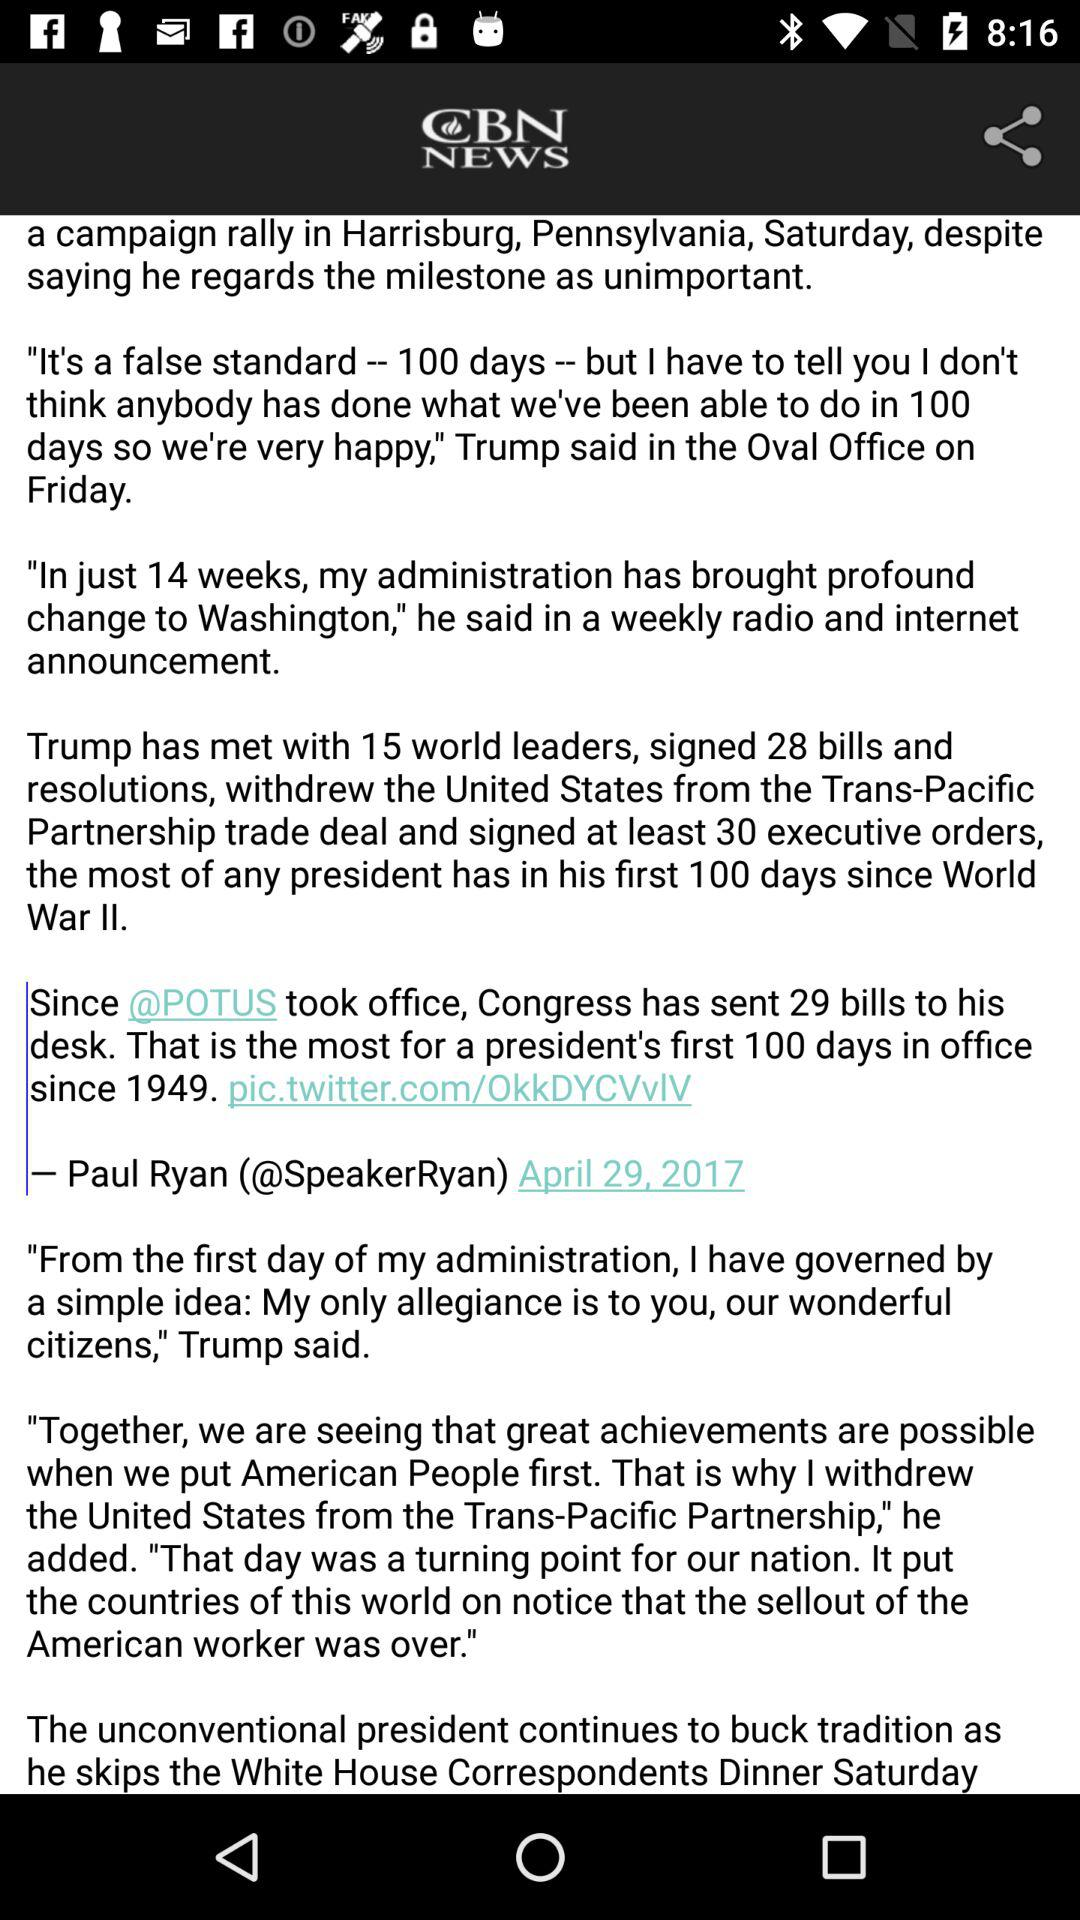How many more executive orders has Trump signed than bills and resolutions combined?
Answer the question using a single word or phrase. 2 